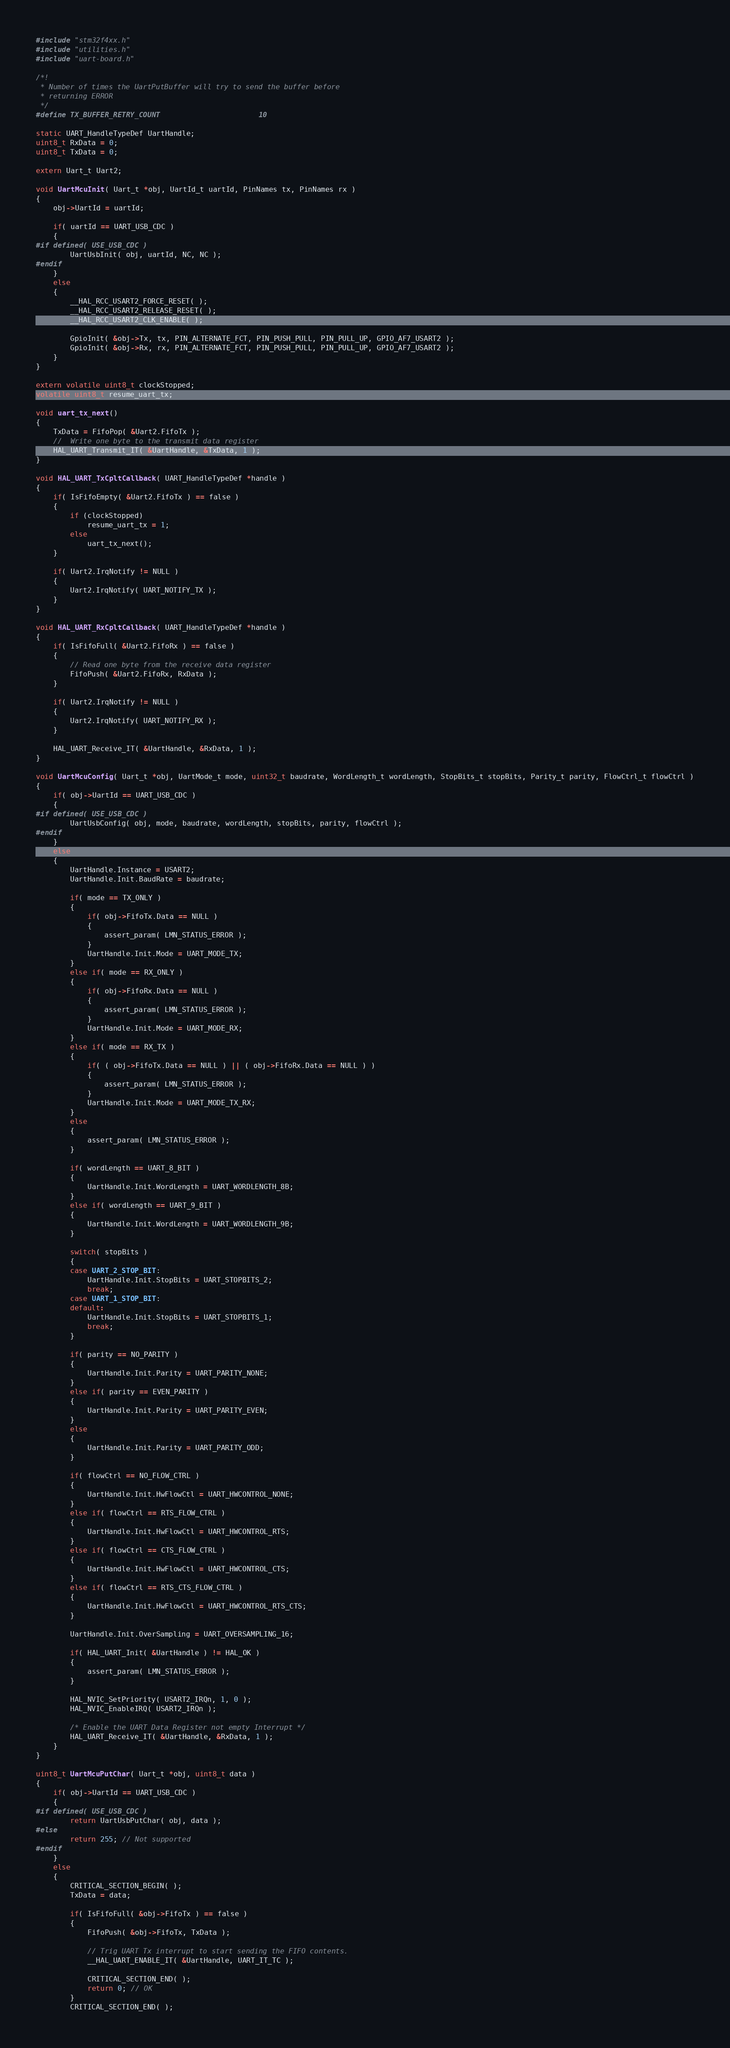<code> <loc_0><loc_0><loc_500><loc_500><_C_>
#include "stm32f4xx.h"
#include "utilities.h"
#include "uart-board.h"

/*!
 * Number of times the UartPutBuffer will try to send the buffer before
 * returning ERROR
 */
#define TX_BUFFER_RETRY_COUNT                       10

static UART_HandleTypeDef UartHandle;
uint8_t RxData = 0;
uint8_t TxData = 0;

extern Uart_t Uart2;

void UartMcuInit( Uart_t *obj, UartId_t uartId, PinNames tx, PinNames rx )
{
    obj->UartId = uartId;

    if( uartId == UART_USB_CDC )
    {
#if defined( USE_USB_CDC )
        UartUsbInit( obj, uartId, NC, NC );
#endif
    }
    else
    {
        __HAL_RCC_USART2_FORCE_RESET( );
        __HAL_RCC_USART2_RELEASE_RESET( );
        __HAL_RCC_USART2_CLK_ENABLE( );

        GpioInit( &obj->Tx, tx, PIN_ALTERNATE_FCT, PIN_PUSH_PULL, PIN_PULL_UP, GPIO_AF7_USART2 );
        GpioInit( &obj->Rx, rx, PIN_ALTERNATE_FCT, PIN_PUSH_PULL, PIN_PULL_UP, GPIO_AF7_USART2 );
    }
}

extern volatile uint8_t clockStopped;
volatile uint8_t resume_uart_tx;

void uart_tx_next()
{
    TxData = FifoPop( &Uart2.FifoTx );
    //  Write one byte to the transmit data register
    HAL_UART_Transmit_IT( &UartHandle, &TxData, 1 );
}

void HAL_UART_TxCpltCallback( UART_HandleTypeDef *handle )
{
    if( IsFifoEmpty( &Uart2.FifoTx ) == false )
    {
        if (clockStopped)
            resume_uart_tx = 1;
        else
            uart_tx_next();
    }

    if( Uart2.IrqNotify != NULL )
    {
        Uart2.IrqNotify( UART_NOTIFY_TX );
    }
}

void HAL_UART_RxCpltCallback( UART_HandleTypeDef *handle )
{
    if( IsFifoFull( &Uart2.FifoRx ) == false )
    {
        // Read one byte from the receive data register
        FifoPush( &Uart2.FifoRx, RxData );
    }

    if( Uart2.IrqNotify != NULL )
    {
        Uart2.IrqNotify( UART_NOTIFY_RX );
    }

    HAL_UART_Receive_IT( &UartHandle, &RxData, 1 );
}

void UartMcuConfig( Uart_t *obj, UartMode_t mode, uint32_t baudrate, WordLength_t wordLength, StopBits_t stopBits, Parity_t parity, FlowCtrl_t flowCtrl )
{
    if( obj->UartId == UART_USB_CDC )
    {
#if defined( USE_USB_CDC )
        UartUsbConfig( obj, mode, baudrate, wordLength, stopBits, parity, flowCtrl );
#endif
    }
    else
    {
        UartHandle.Instance = USART2;
        UartHandle.Init.BaudRate = baudrate;

        if( mode == TX_ONLY )
        {
            if( obj->FifoTx.Data == NULL )
            {
                assert_param( LMN_STATUS_ERROR );
            }
            UartHandle.Init.Mode = UART_MODE_TX;
        }
        else if( mode == RX_ONLY )
        {
            if( obj->FifoRx.Data == NULL )
            {
                assert_param( LMN_STATUS_ERROR );
            }
            UartHandle.Init.Mode = UART_MODE_RX;
        }
        else if( mode == RX_TX )
        {
            if( ( obj->FifoTx.Data == NULL ) || ( obj->FifoRx.Data == NULL ) )
            {
                assert_param( LMN_STATUS_ERROR );
            }
            UartHandle.Init.Mode = UART_MODE_TX_RX;
        }
        else
        {
            assert_param( LMN_STATUS_ERROR );
        }

        if( wordLength == UART_8_BIT )
        {
            UartHandle.Init.WordLength = UART_WORDLENGTH_8B;
        }
        else if( wordLength == UART_9_BIT )
        {
            UartHandle.Init.WordLength = UART_WORDLENGTH_9B;
        }

        switch( stopBits )
        {
        case UART_2_STOP_BIT:
            UartHandle.Init.StopBits = UART_STOPBITS_2;
            break;
        case UART_1_STOP_BIT:
        default:
            UartHandle.Init.StopBits = UART_STOPBITS_1;
            break;
        }

        if( parity == NO_PARITY )
        {
            UartHandle.Init.Parity = UART_PARITY_NONE;
        }
        else if( parity == EVEN_PARITY )
        {
            UartHandle.Init.Parity = UART_PARITY_EVEN;
        }
        else
        {
            UartHandle.Init.Parity = UART_PARITY_ODD;
        }

        if( flowCtrl == NO_FLOW_CTRL )
        {
            UartHandle.Init.HwFlowCtl = UART_HWCONTROL_NONE;
        }
        else if( flowCtrl == RTS_FLOW_CTRL )
        {
            UartHandle.Init.HwFlowCtl = UART_HWCONTROL_RTS;
        }
        else if( flowCtrl == CTS_FLOW_CTRL )
        {
            UartHandle.Init.HwFlowCtl = UART_HWCONTROL_CTS;
        }
        else if( flowCtrl == RTS_CTS_FLOW_CTRL )
        {
            UartHandle.Init.HwFlowCtl = UART_HWCONTROL_RTS_CTS;
        }

        UartHandle.Init.OverSampling = UART_OVERSAMPLING_16;

        if( HAL_UART_Init( &UartHandle ) != HAL_OK )
        {
            assert_param( LMN_STATUS_ERROR );
        }

        HAL_NVIC_SetPriority( USART2_IRQn, 1, 0 );
        HAL_NVIC_EnableIRQ( USART2_IRQn );

        /* Enable the UART Data Register not empty Interrupt */
        HAL_UART_Receive_IT( &UartHandle, &RxData, 1 );
    }
}

uint8_t UartMcuPutChar( Uart_t *obj, uint8_t data )
{
    if( obj->UartId == UART_USB_CDC )
    {
#if defined( USE_USB_CDC )
        return UartUsbPutChar( obj, data );
#else
        return 255; // Not supported
#endif
    }
    else
    {
        CRITICAL_SECTION_BEGIN( );
        TxData = data;

        if( IsFifoFull( &obj->FifoTx ) == false )
        {
            FifoPush( &obj->FifoTx, TxData );

            // Trig UART Tx interrupt to start sending the FIFO contents.
            __HAL_UART_ENABLE_IT( &UartHandle, UART_IT_TC );

            CRITICAL_SECTION_END( );
            return 0; // OK
        }
        CRITICAL_SECTION_END( );</code> 